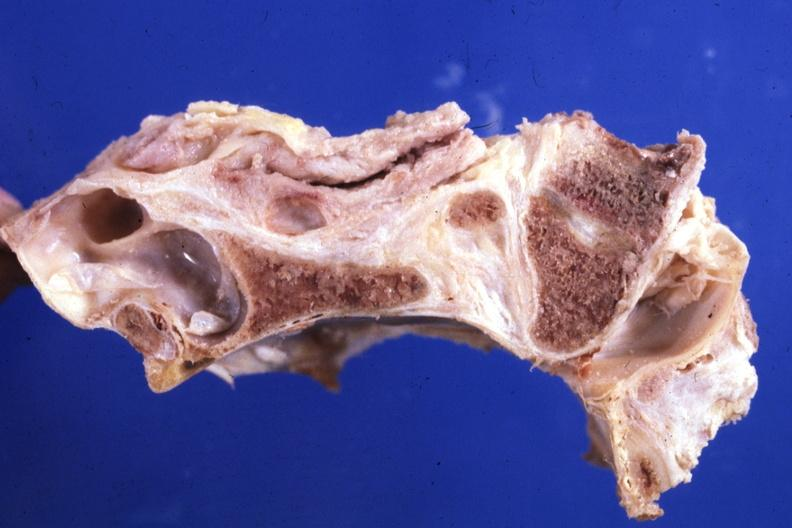does this image show sagittal section of atlas vertebra and occipital bone foramen magnum stenosis case 31?
Answer the question using a single word or phrase. Yes 